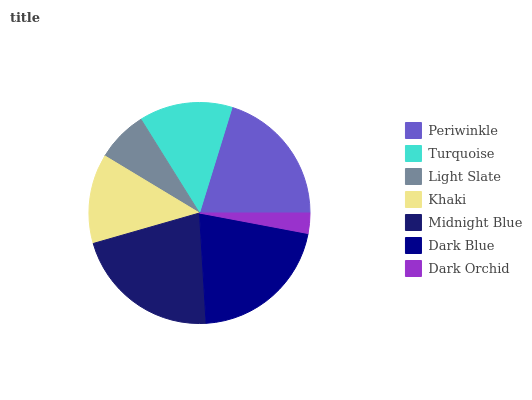Is Dark Orchid the minimum?
Answer yes or no. Yes. Is Midnight Blue the maximum?
Answer yes or no. Yes. Is Turquoise the minimum?
Answer yes or no. No. Is Turquoise the maximum?
Answer yes or no. No. Is Periwinkle greater than Turquoise?
Answer yes or no. Yes. Is Turquoise less than Periwinkle?
Answer yes or no. Yes. Is Turquoise greater than Periwinkle?
Answer yes or no. No. Is Periwinkle less than Turquoise?
Answer yes or no. No. Is Turquoise the high median?
Answer yes or no. Yes. Is Turquoise the low median?
Answer yes or no. Yes. Is Dark Orchid the high median?
Answer yes or no. No. Is Dark Orchid the low median?
Answer yes or no. No. 